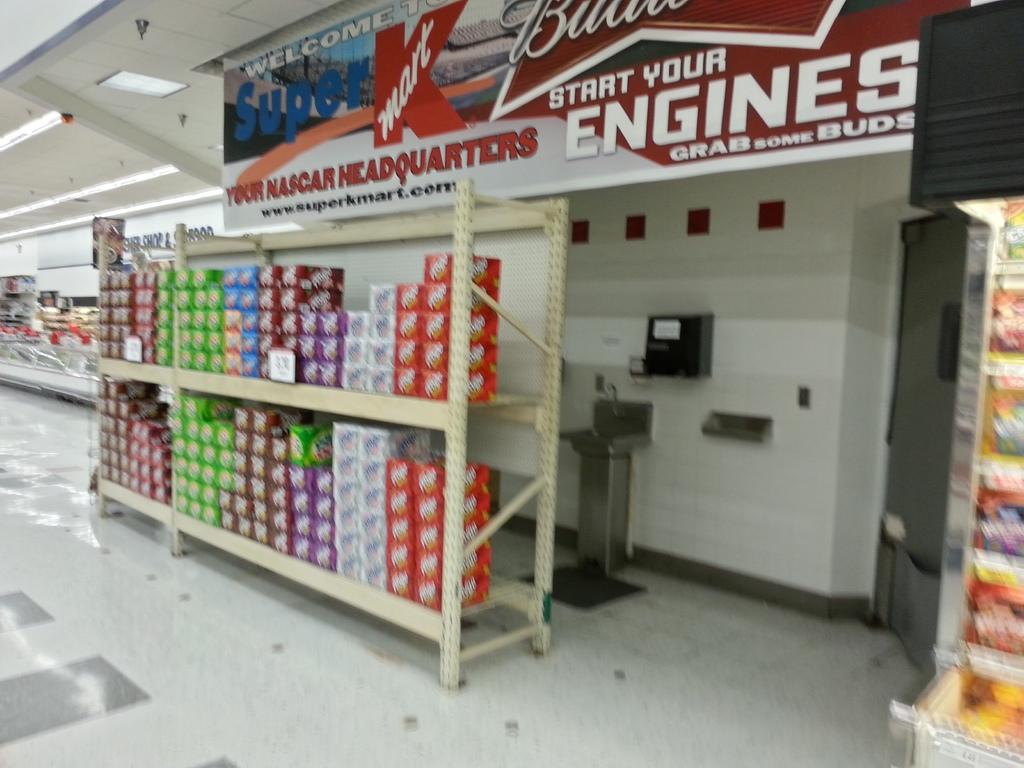<image>
Write a terse but informative summary of the picture. A sign states that Kmart is "your Nascar Headquarters." 